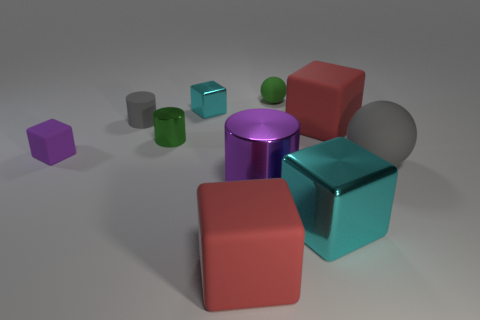Is the color of the tiny metallic block the same as the large rubber cube behind the gray sphere? The mentioned tiny metallic block displays a distinct violet hue, whereas the large rubber cube in the background exudes a soft turquoise shade. These colors, while both visually appealing, are not the same—the metallic block has a deeper, purple undertone, in contrast to the cube's blue-green tint. 